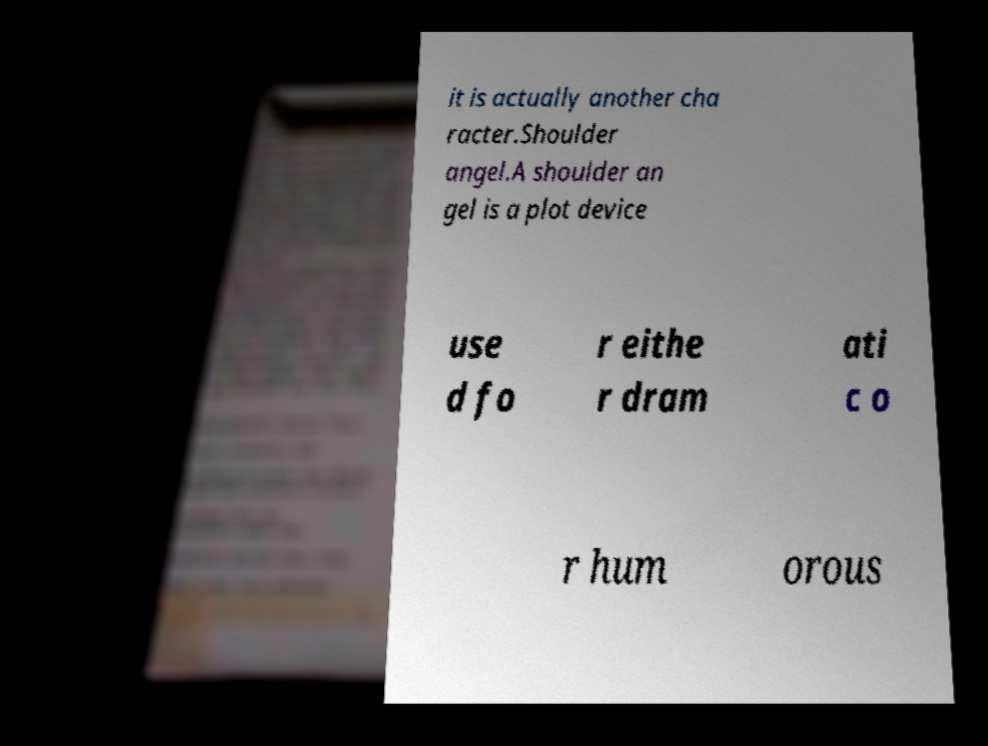Can you accurately transcribe the text from the provided image for me? it is actually another cha racter.Shoulder angel.A shoulder an gel is a plot device use d fo r eithe r dram ati c o r hum orous 